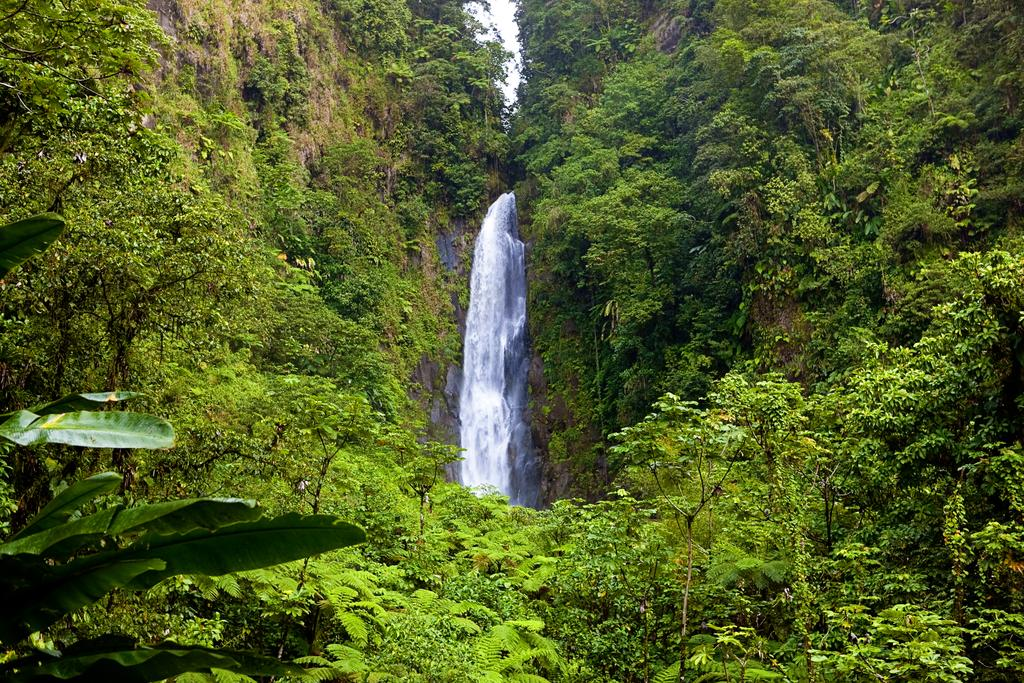How many mountains are visible in the image? There are two mountains in the image. What is located between the mountains? There is a waterfall between the mountains. What type of vegetation surrounds the mountains? The mountains are surrounded by green trees. Can you see any fear, robin, or fairies in the image? No, there are no fear, robin, or fairies present in the image. 